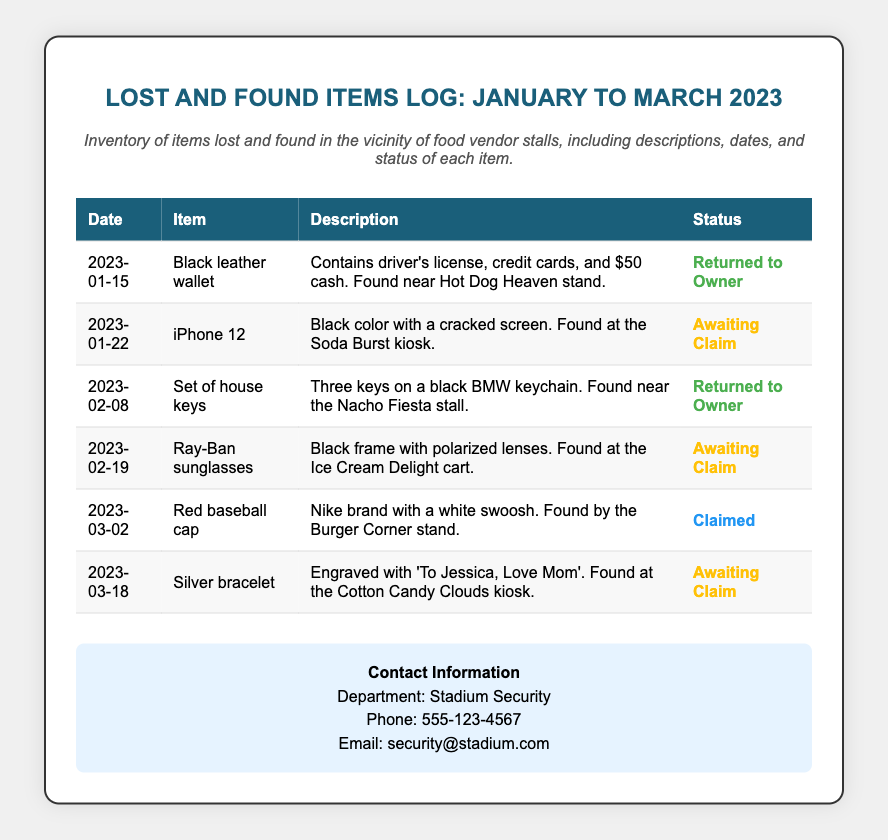What item was returned to its owner on January 15? The item returned to its owner is the black leather wallet found near the Hot Dog Heaven stand.
Answer: Black leather wallet What is the status of the iPhone 12? The iPhone 12 is currently awaiting a claim, as noted in the document.
Answer: Awaiting Claim When were the Ray-Ban sunglasses found? The Ray-Ban sunglasses were found on February 19, as indicated in the log.
Answer: February 19 How many items are awaiting claim? There are three items awaiting claim based on the list in the document.
Answer: Three Which item was claimed on March 2? The item claimed was the red baseball cap found by the Burger Corner stand.
Answer: Red baseball cap What is the description of the silver bracelet? The silver bracelet is engraved with 'To Jessica, Love Mom', providing a specific detail about it.
Answer: Engraved with 'To Jessica, Love Mom' What was found at the Ice Cream Delight cart? At the Ice Cream Delight cart, Ray-Ban sunglasses were found, according to the entry.
Answer: Ray-Ban sunglasses What brand is the red baseball cap? The red baseball cap is a Nike brand, as mentioned in the description.
Answer: Nike What is the contact phone number for Stadium Security? The contact phone number for Stadium Security provided in the document is 555-123-4567.
Answer: 555-123-4567 